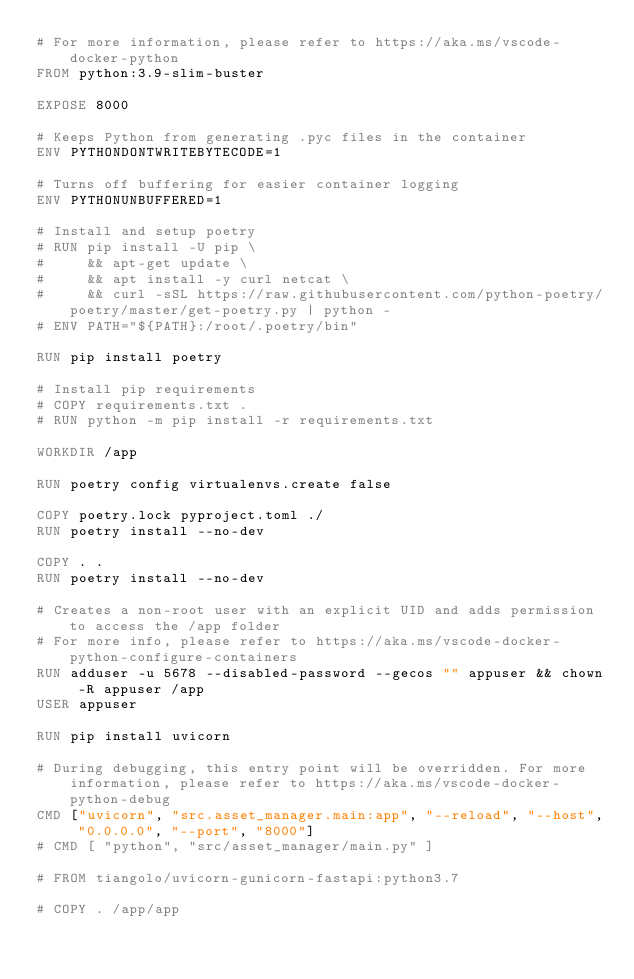<code> <loc_0><loc_0><loc_500><loc_500><_Dockerfile_># For more information, please refer to https://aka.ms/vscode-docker-python
FROM python:3.9-slim-buster

EXPOSE 8000

# Keeps Python from generating .pyc files in the container
ENV PYTHONDONTWRITEBYTECODE=1

# Turns off buffering for easier container logging
ENV PYTHONUNBUFFERED=1

# Install and setup poetry
# RUN pip install -U pip \
#     && apt-get update \
#     && apt install -y curl netcat \
#     && curl -sSL https://raw.githubusercontent.com/python-poetry/poetry/master/get-poetry.py | python -
# ENV PATH="${PATH}:/root/.poetry/bin"

RUN pip install poetry

# Install pip requirements
# COPY requirements.txt .
# RUN python -m pip install -r requirements.txt

WORKDIR /app

RUN poetry config virtualenvs.create false

COPY poetry.lock pyproject.toml ./
RUN poetry install --no-dev

COPY . .
RUN poetry install --no-dev

# Creates a non-root user with an explicit UID and adds permission to access the /app folder
# For more info, please refer to https://aka.ms/vscode-docker-python-configure-containers
RUN adduser -u 5678 --disabled-password --gecos "" appuser && chown -R appuser /app
USER appuser

RUN pip install uvicorn

# During debugging, this entry point will be overridden. For more information, please refer to https://aka.ms/vscode-docker-python-debug
CMD ["uvicorn", "src.asset_manager.main:app", "--reload", "--host", "0.0.0.0", "--port", "8000"]
# CMD [ "python", "src/asset_manager/main.py" ]

# FROM tiangolo/uvicorn-gunicorn-fastapi:python3.7

# COPY . /app/app</code> 